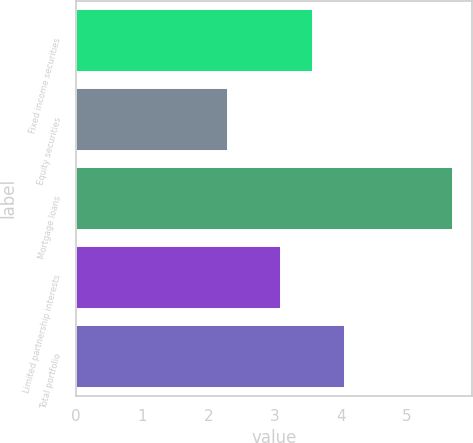<chart> <loc_0><loc_0><loc_500><loc_500><bar_chart><fcel>Fixed income securities<fcel>Equity securities<fcel>Mortgage loans<fcel>Limited partnership interests<fcel>Total portfolio<nl><fcel>3.58<fcel>2.3<fcel>5.7<fcel>3.1<fcel>4.06<nl></chart> 